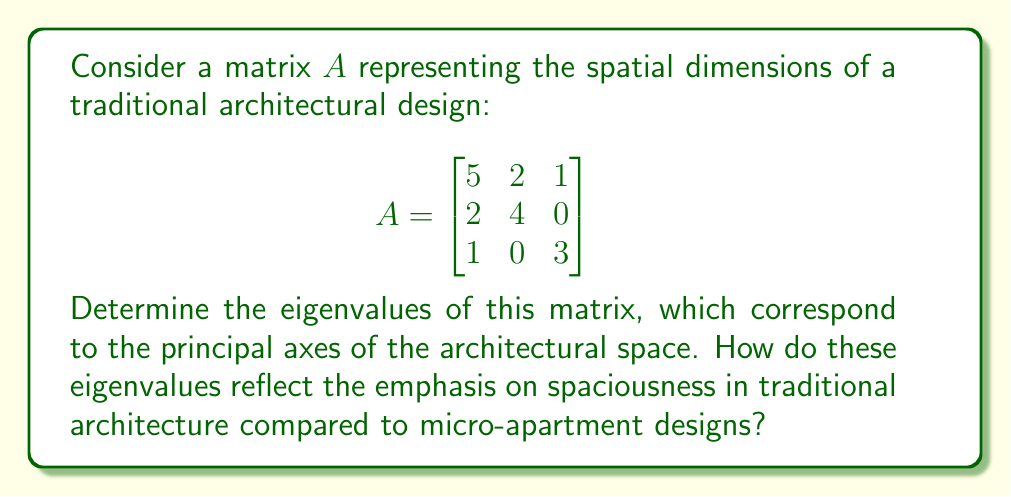Could you help me with this problem? To find the eigenvalues of matrix $A$, we need to solve the characteristic equation:

1) First, we set up the equation $\det(A - \lambda I) = 0$, where $I$ is the 3x3 identity matrix:

   $$\det\begin{pmatrix}
   5-\lambda & 2 & 1 \\
   2 & 4-\lambda & 0 \\
   1 & 0 & 3-\lambda
   \end{pmatrix} = 0$$

2) Expand the determinant:
   $$(5-\lambda)[(4-\lambda)(3-\lambda) - 0] - 2[2(3-\lambda) - 0] + 1[2 \cdot 0 - 1(4-\lambda)] = 0$$

3) Simplify:
   $$(5-\lambda)(12-7\lambda+\lambda^2) - 2(6-2\lambda) - (4-\lambda) = 0$$
   
4) Expand further:
   $$60-35\lambda+5\lambda^2-12\lambda+7\lambda^2-\lambda^3 - 12+4\lambda - 4+\lambda = 0$$

5) Collect like terms:
   $$-\lambda^3 + 12\lambda^2 - 42\lambda + 44 = 0$$

6) This is a cubic equation. We can solve it by factoring or using the cubic formula. By inspection or using a computer algebra system, we find the roots are:

   $\lambda_1 = 2$, $\lambda_2 = 4$, $\lambda_3 = 6$

These eigenvalues represent the principal dimensions of the architectural space. The larger values (4 and 6) indicate an emphasis on spaciousness in two primary directions, which is characteristic of traditional architecture. This contrasts sharply with micro-apartment designs, where spatial dimensions would be much more constrained, likely resulting in smaller eigenvalues.
Answer: $\lambda_1 = 2$, $\lambda_2 = 4$, $\lambda_3 = 6$ 